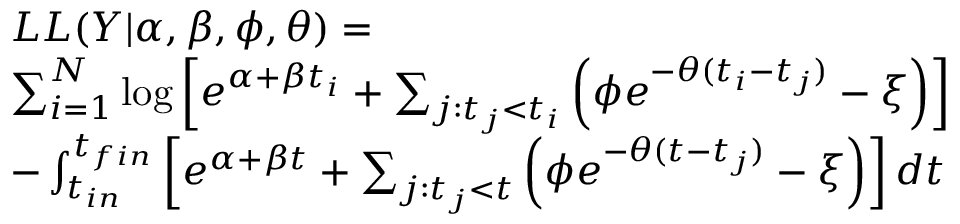Convert formula to latex. <formula><loc_0><loc_0><loc_500><loc_500>\begin{array} { r l } & { L L ( Y | \alpha , \beta , \phi , \theta ) = } \\ & { \sum _ { i = 1 } ^ { N } \log \left [ e ^ { \alpha + \beta t _ { i } } + \sum _ { j \colon t _ { j } < t _ { i } } \left ( \phi e ^ { - \theta ( t _ { i } - t _ { j } ) } - \xi \right ) \right ] } \\ & { - \int _ { t _ { i n } } ^ { t _ { f i n } } \left [ e ^ { \alpha + \beta t } + \sum _ { j \colon t _ { j } < t } \left ( \phi e ^ { - \theta ( t - t _ { j } ) } - \xi \right ) \right ] d t } \end{array}</formula> 